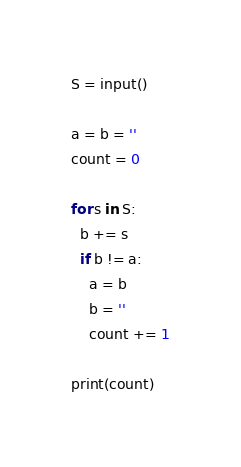<code> <loc_0><loc_0><loc_500><loc_500><_Python_>S = input()

a = b = ''
count = 0

for s in S:
  b += s
  if b != a:
    a = b
    b = ''
    count += 1

print(count)</code> 